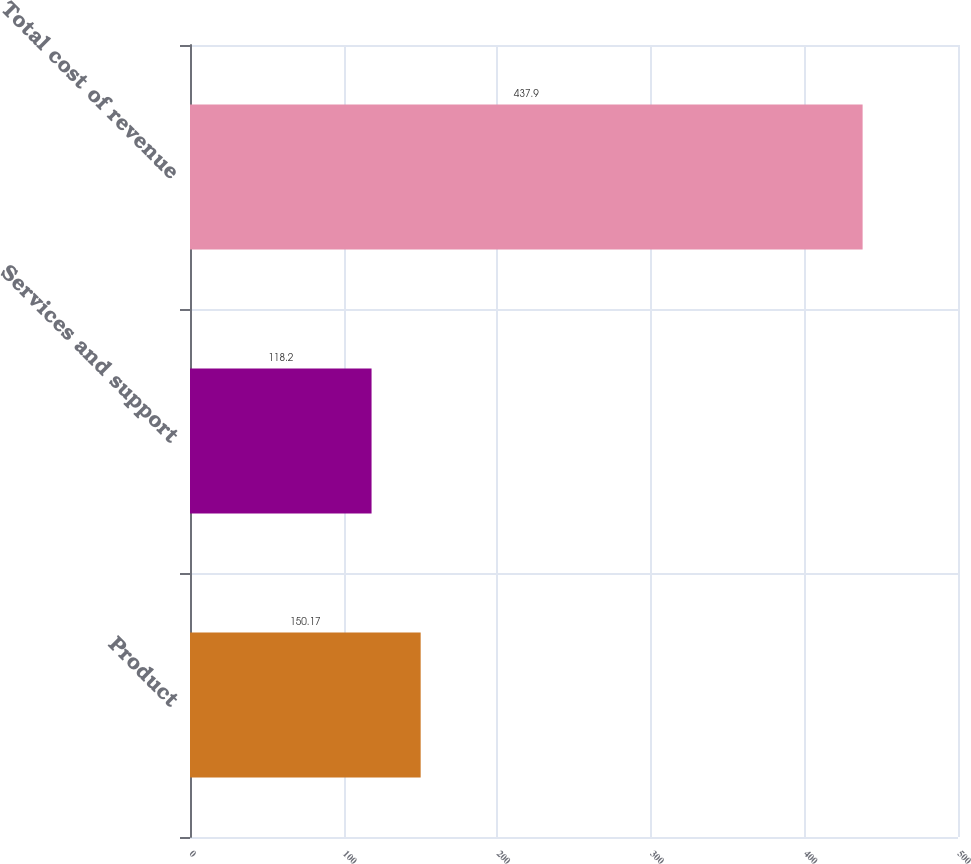Convert chart to OTSL. <chart><loc_0><loc_0><loc_500><loc_500><bar_chart><fcel>Product<fcel>Services and support<fcel>Total cost of revenue<nl><fcel>150.17<fcel>118.2<fcel>437.9<nl></chart> 